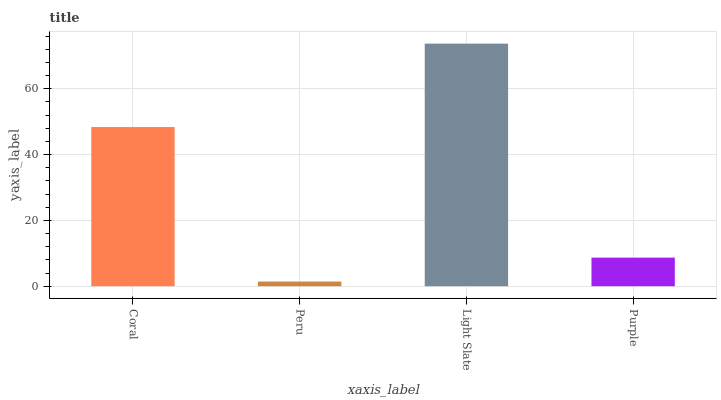Is Peru the minimum?
Answer yes or no. Yes. Is Light Slate the maximum?
Answer yes or no. Yes. Is Light Slate the minimum?
Answer yes or no. No. Is Peru the maximum?
Answer yes or no. No. Is Light Slate greater than Peru?
Answer yes or no. Yes. Is Peru less than Light Slate?
Answer yes or no. Yes. Is Peru greater than Light Slate?
Answer yes or no. No. Is Light Slate less than Peru?
Answer yes or no. No. Is Coral the high median?
Answer yes or no. Yes. Is Purple the low median?
Answer yes or no. Yes. Is Peru the high median?
Answer yes or no. No. Is Peru the low median?
Answer yes or no. No. 